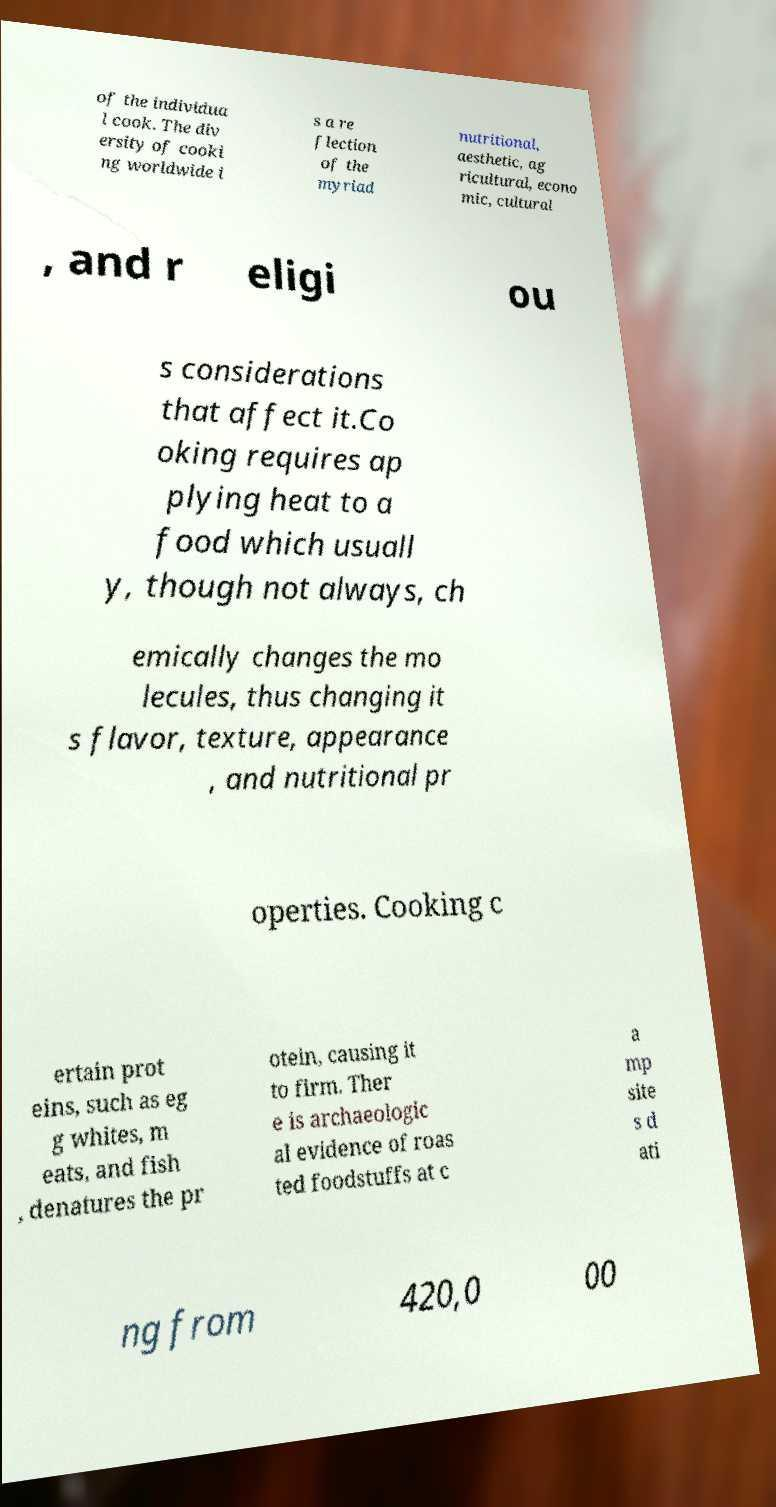There's text embedded in this image that I need extracted. Can you transcribe it verbatim? of the individua l cook. The div ersity of cooki ng worldwide i s a re flection of the myriad nutritional, aesthetic, ag ricultural, econo mic, cultural , and r eligi ou s considerations that affect it.Co oking requires ap plying heat to a food which usuall y, though not always, ch emically changes the mo lecules, thus changing it s flavor, texture, appearance , and nutritional pr operties. Cooking c ertain prot eins, such as eg g whites, m eats, and fish , denatures the pr otein, causing it to firm. Ther e is archaeologic al evidence of roas ted foodstuffs at c a mp site s d ati ng from 420,0 00 